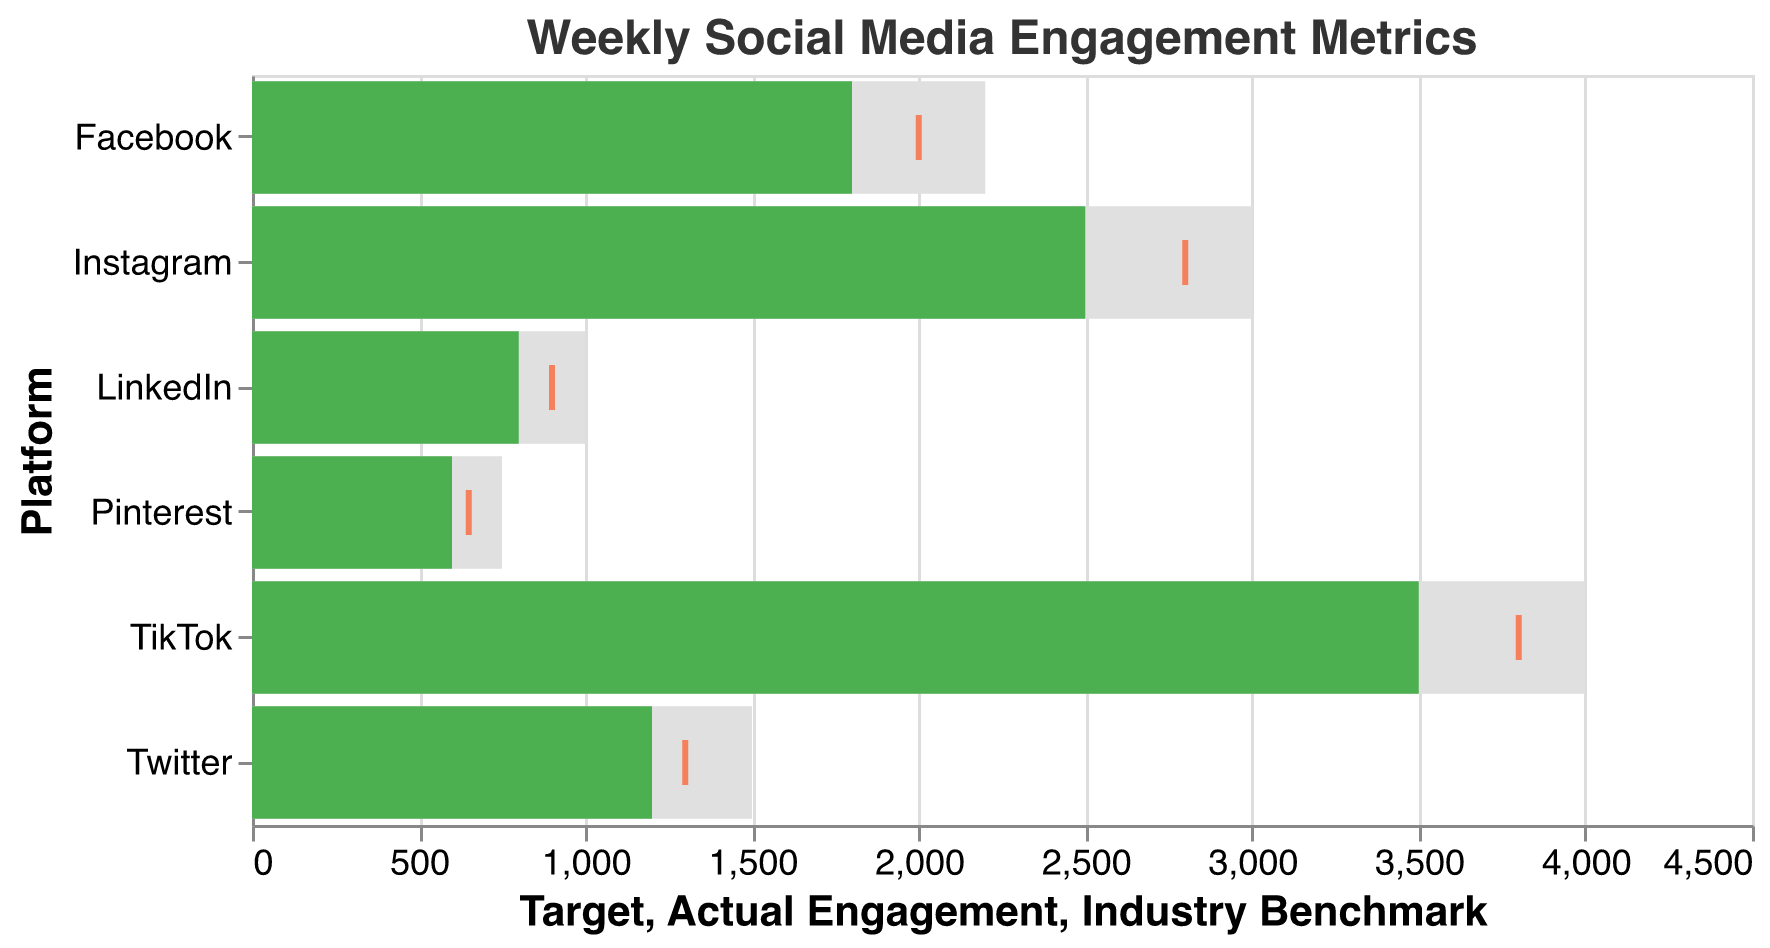What is the title of the chart? The title of the chart is "Weekly Social Media Engagement Metrics," which is written at the top of the chart in Helvetica font with a font size of 16 and color #333333.
Answer: Weekly Social Media Engagement Metrics What is the actual engagement value for TikTok? Find the bar labeled "TikTok" and look at the green bar value, which represents the actual engagement. It's labeled as 3500.
Answer: 3500 How does the actual engagement for Facebook compare to its target engagement? Compare the green bar (actual engagement) and the gray bar (target engagement) for Facebook. The actual engagement is 1800, while the target engagement is 2200.
Answer: Actual engagement is 400 less than the target Are any of the platforms exceeding their target engagement? Compare the green bar (actual engagement) with the gray bar (target engagement) for each platform. In the chart, no green bar (actual engagement) exceeds its corresponding gray bar (target engagement) for any platform.
Answer: No What is the color used for the industry benchmark tick? The industry benchmark is represented by a tick mark in the chart. These ticks are colored orange (#FF5722).
Answer: Orange Which platform has the highest industry benchmark? Check the values associated with the industry benchmark tick for each platform. TikTok has the highest industry benchmark at 3800.
Answer: TikTok How much higher is the target engagement for Pinterest compared to its industry benchmark? Subtract the industry benchmark value from the target value for Pinterest: Target (750) - Industry Benchmark (650) = 100.
Answer: 100 What is the average actual engagement across all platforms? Add up the actual engagement values and divide by the number of platforms: (2500 + 1800 + 1200 + 800 + 600 + 3500) / 6 = 10400 / 6 = 1733.33.
Answer: 1733.33 Which platform is closest to meeting its target engagement based on actual engagement? Calculate how close each platform is to its target engagement: Instagram (2500/3000=83.33%), Facebook (1800/2200=81.82%), Twitter (1200/1500=80%), LinkedIn (800/1000=80%), Pinterest (600/750=80%), TikTok (3500/4000=87.5%). TikTok is the closest at 87.5%.
Answer: TikTok 